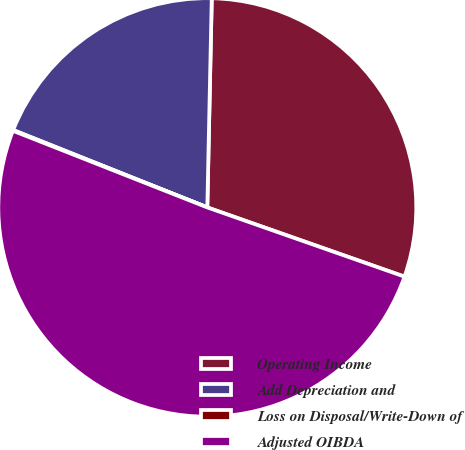<chart> <loc_0><loc_0><loc_500><loc_500><pie_chart><fcel>Operating Income<fcel>Add Depreciation and<fcel>Loss on Disposal/Write-Down of<fcel>Adjusted OIBDA<nl><fcel>30.03%<fcel>19.31%<fcel>0.06%<fcel>50.61%<nl></chart> 